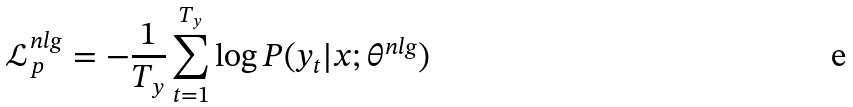<formula> <loc_0><loc_0><loc_500><loc_500>\mathcal { L } _ { p } ^ { n l g } = - \frac { 1 } { T _ { y } } \sum _ { t = 1 } ^ { T _ { y } } \log P ( y _ { t } | x ; \theta ^ { n l g } )</formula> 